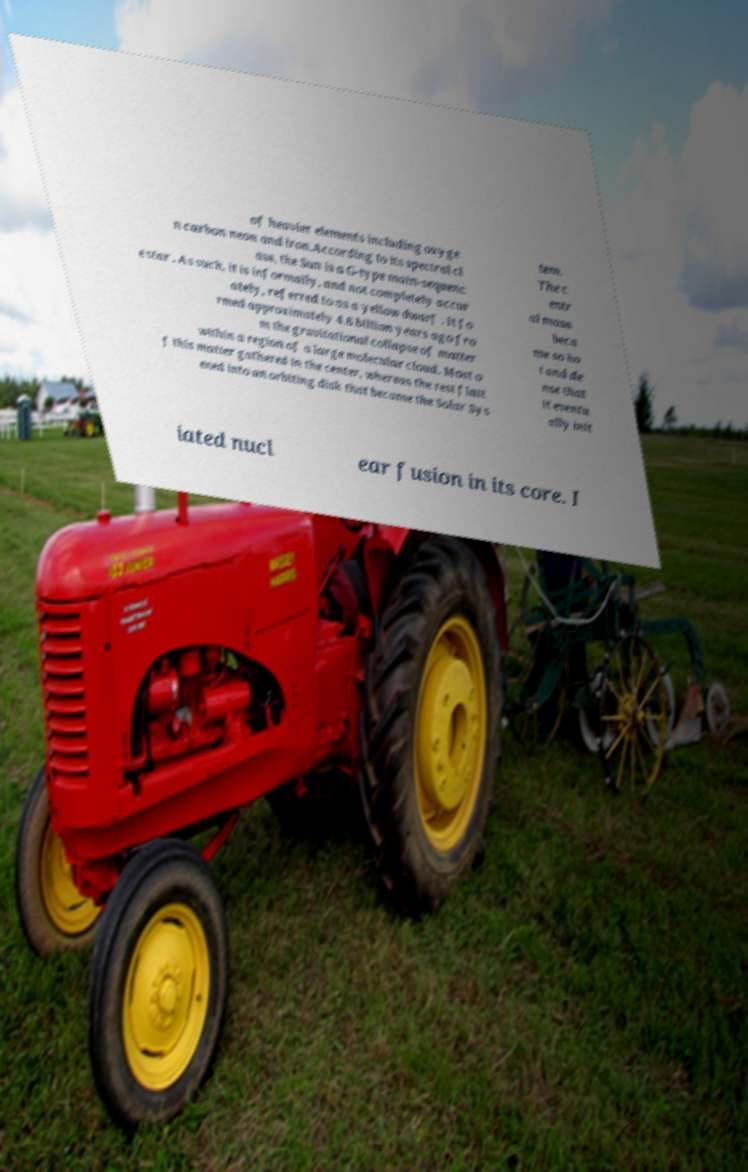Could you assist in decoding the text presented in this image and type it out clearly? of heavier elements including oxyge n carbon neon and iron.According to its spectral cl ass, the Sun is a G-type main-sequenc e star . As such, it is informally, and not completely accur ately, referred to as a yellow dwarf . It fo rmed approximately 4.6 billion years ago fro m the gravitational collapse of matter within a region of a large molecular cloud. Most o f this matter gathered in the center, whereas the rest flatt ened into an orbiting disk that became the Solar Sys tem. The c entr al mass beca me so ho t and de nse that it eventu ally init iated nucl ear fusion in its core. I 